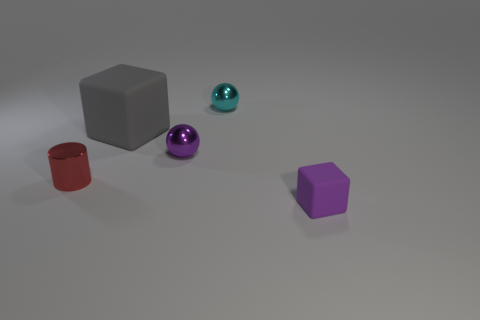There is a tiny purple thing that is the same material as the gray object; what shape is it?
Provide a short and direct response. Cube. Are there fewer big cyan spheres than balls?
Provide a short and direct response. Yes. There is a thing that is both to the left of the tiny cyan ball and to the right of the big matte object; what is its material?
Your answer should be compact. Metal. What size is the purple thing that is behind the small purple object that is to the right of the sphere left of the tiny cyan metal ball?
Ensure brevity in your answer.  Small. There is a big rubber object; is it the same shape as the rubber thing that is in front of the large gray matte cube?
Give a very brief answer. Yes. What number of things are behind the tiny block and in front of the large gray thing?
Your answer should be compact. 2. What number of yellow things are either metallic things or small cylinders?
Give a very brief answer. 0. Is the color of the cube that is left of the purple sphere the same as the tiny metal ball that is in front of the cyan metal object?
Provide a succinct answer. No. What is the color of the object that is in front of the metal object that is to the left of the matte cube that is behind the purple cube?
Provide a short and direct response. Purple. There is a big gray rubber object that is in front of the cyan sphere; are there any small purple rubber cubes that are behind it?
Provide a short and direct response. No. 